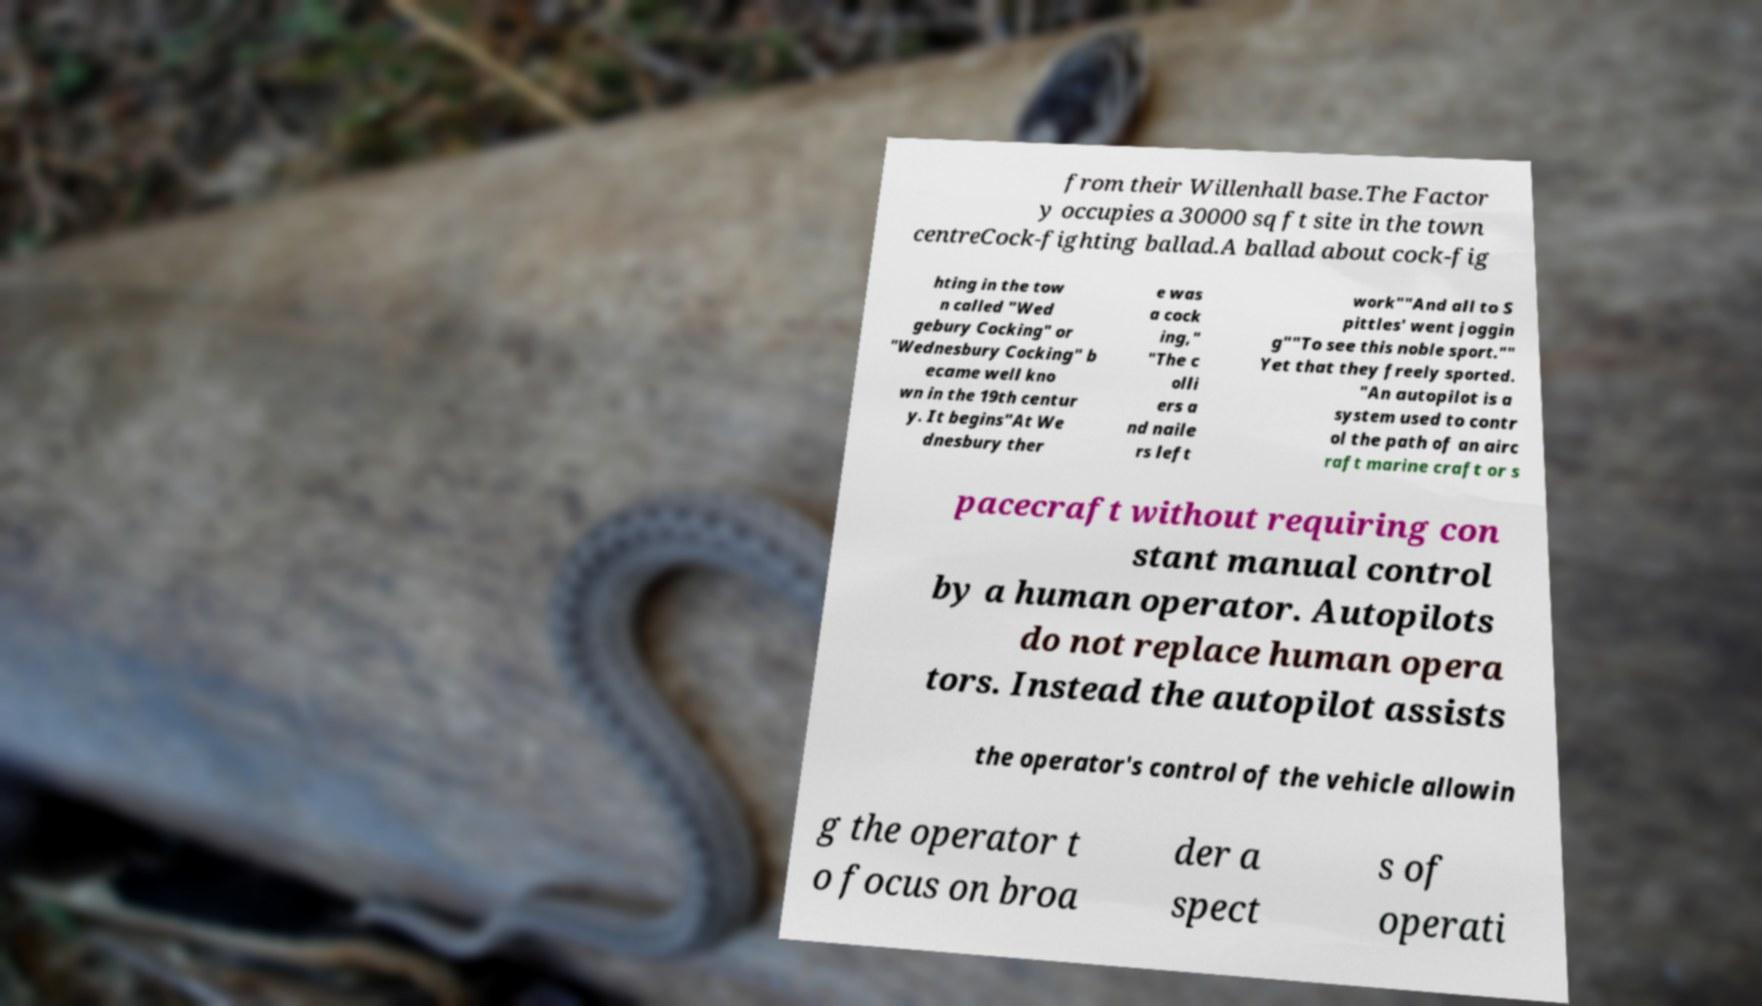Please identify and transcribe the text found in this image. from their Willenhall base.The Factor y occupies a 30000 sq ft site in the town centreCock-fighting ballad.A ballad about cock-fig hting in the tow n called "Wed gebury Cocking" or "Wednesbury Cocking" b ecame well kno wn in the 19th centur y. It begins"At We dnesbury ther e was a cock ing," "The c olli ers a nd naile rs left work""And all to S pittles' went joggin g""To see this noble sport."" Yet that they freely sported. "An autopilot is a system used to contr ol the path of an airc raft marine craft or s pacecraft without requiring con stant manual control by a human operator. Autopilots do not replace human opera tors. Instead the autopilot assists the operator's control of the vehicle allowin g the operator t o focus on broa der a spect s of operati 